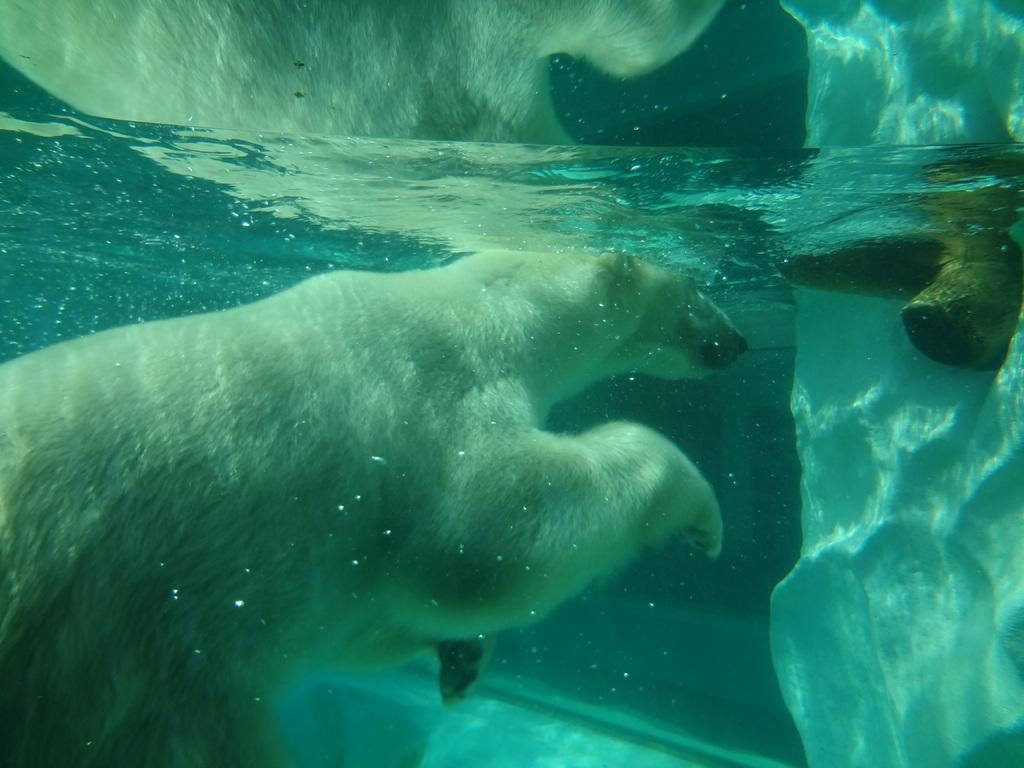What is the main element in the image? There is water in the image. What animal can be seen in the water? There is a white-colored polar bear in the water. What can be seen on the right side of the image? There is a white-colored object on the right side of the image. Are there any other objects near the white-colored object? Yes, there is another object near the white-colored object on the right side of the image. What type of cherry is the manager holding in the image? There is no manager or cherry present in the image. How many stitches are visible on the polar bear in the image? The polar bear in the image is not a stuffed animal, so there are no visible stitches. 